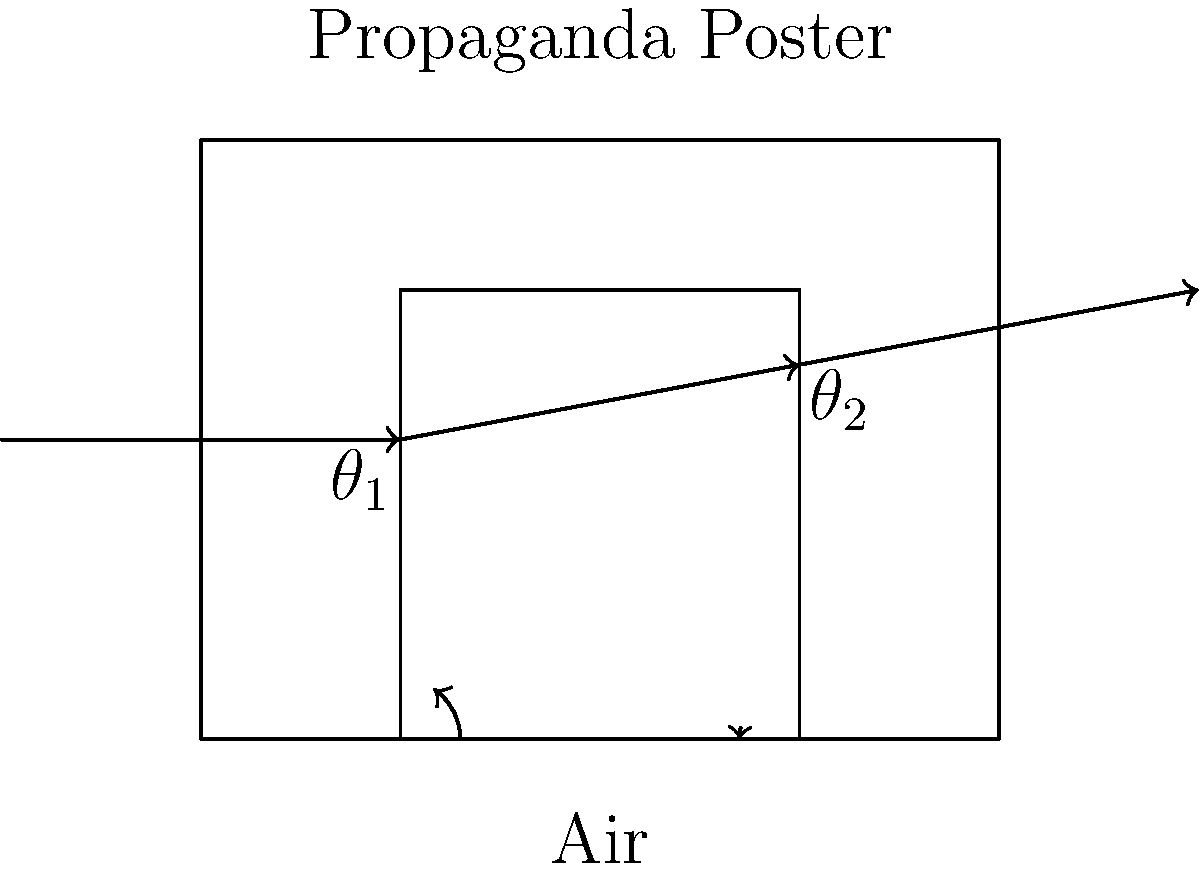In the context of political propaganda, consider a light ray passing through a propaganda poster as shown in the diagram. If the refractive index of the poster material is 1.5 and the angle of incidence $\theta_1$ is 30°, calculate the angle of refraction $\theta_2$. How might this physical principle be metaphorically applied to analyze the "bending" of information in political messaging? To solve this problem, we'll use Snell's law and then discuss its metaphorical implications:

1) Snell's law states: $n_1 \sin(\theta_1) = n_2 \sin(\theta_2)$

2) Given:
   - $n_1 = 1$ (air)
   - $n_2 = 1.5$ (propaganda poster material)
   - $\theta_1 = 30°$

3) Substituting into Snell's law:
   $1 \cdot \sin(30°) = 1.5 \cdot \sin(\theta_2)$

4) Simplify:
   $0.5 = 1.5 \sin(\theta_2)$

5) Solve for $\theta_2$:
   $\sin(\theta_2) = \frac{0.5}{1.5} = \frac{1}{3}$

6) Take the inverse sine (arcsin) of both sides:
   $\theta_2 = \arcsin(\frac{1}{3}) \approx 19.47°$

Metaphorical application:
Just as light bends when passing through materials of different densities, information can be "refracted" or distorted when passing through different media or ideological lenses. In propaganda:

1) The "angle of incidence" could represent the original facts or events.
2) The "refractive index" could symbolize the ideological bias or agenda of the propaganda.
3) The "angle of refraction" might represent how the information is perceived after being manipulated.

This metaphor illustrates how propaganda can subtly alter the perception of reality, much like how light's path is altered when passing through different materials. The degree of "bending" (distortion) depends on the "density" (intensity) of the propaganda's bias.
Answer: $\theta_2 \approx 19.47°$; Propaganda "refracts" information, distorting perception based on ideological bias. 